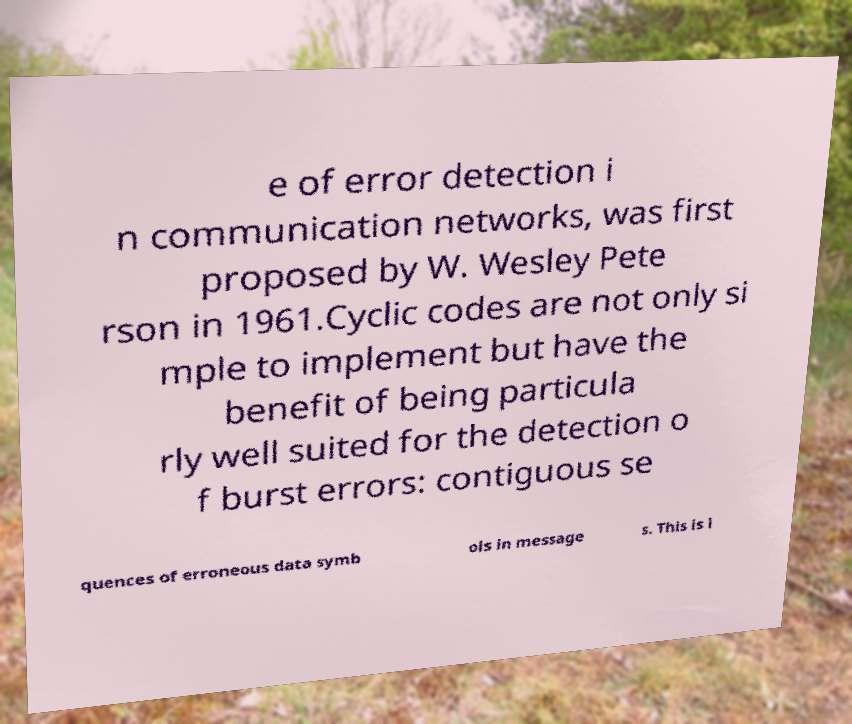There's text embedded in this image that I need extracted. Can you transcribe it verbatim? e of error detection i n communication networks, was first proposed by W. Wesley Pete rson in 1961.Cyclic codes are not only si mple to implement but have the benefit of being particula rly well suited for the detection o f burst errors: contiguous se quences of erroneous data symb ols in message s. This is i 